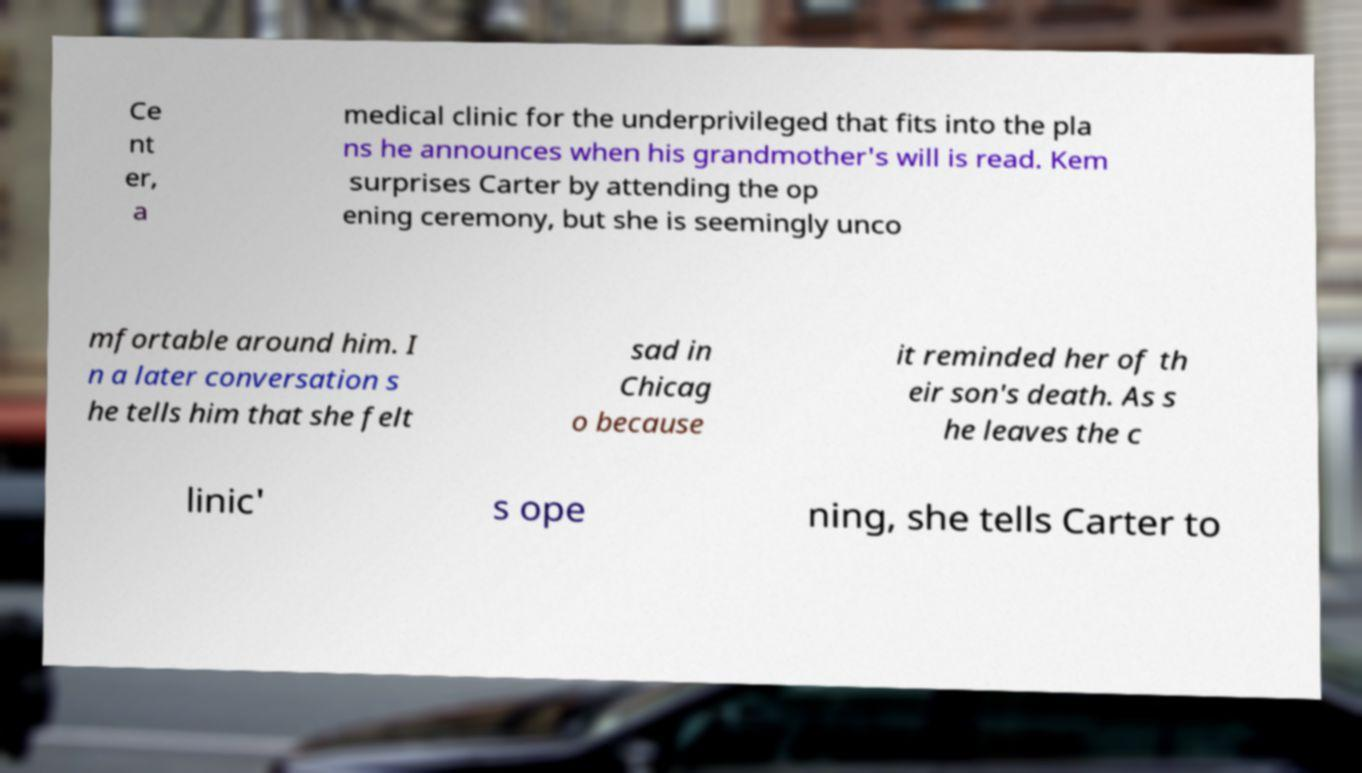Can you read and provide the text displayed in the image?This photo seems to have some interesting text. Can you extract and type it out for me? Ce nt er, a medical clinic for the underprivileged that fits into the pla ns he announces when his grandmother's will is read. Kem surprises Carter by attending the op ening ceremony, but she is seemingly unco mfortable around him. I n a later conversation s he tells him that she felt sad in Chicag o because it reminded her of th eir son's death. As s he leaves the c linic' s ope ning, she tells Carter to 